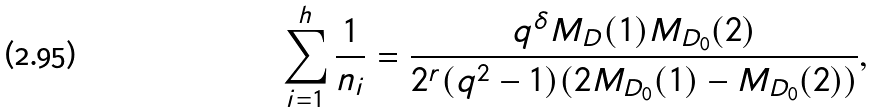Convert formula to latex. <formula><loc_0><loc_0><loc_500><loc_500>\sum _ { i = 1 } ^ { h } \frac { 1 } { n _ { i } } = \frac { q ^ { \delta } M _ { D } ( 1 ) M _ { D _ { 0 } } ( 2 ) } { 2 ^ { r } ( q ^ { 2 } - 1 ) ( 2 M _ { D _ { 0 } } ( 1 ) - M _ { D _ { 0 } } ( 2 ) ) } ,</formula> 